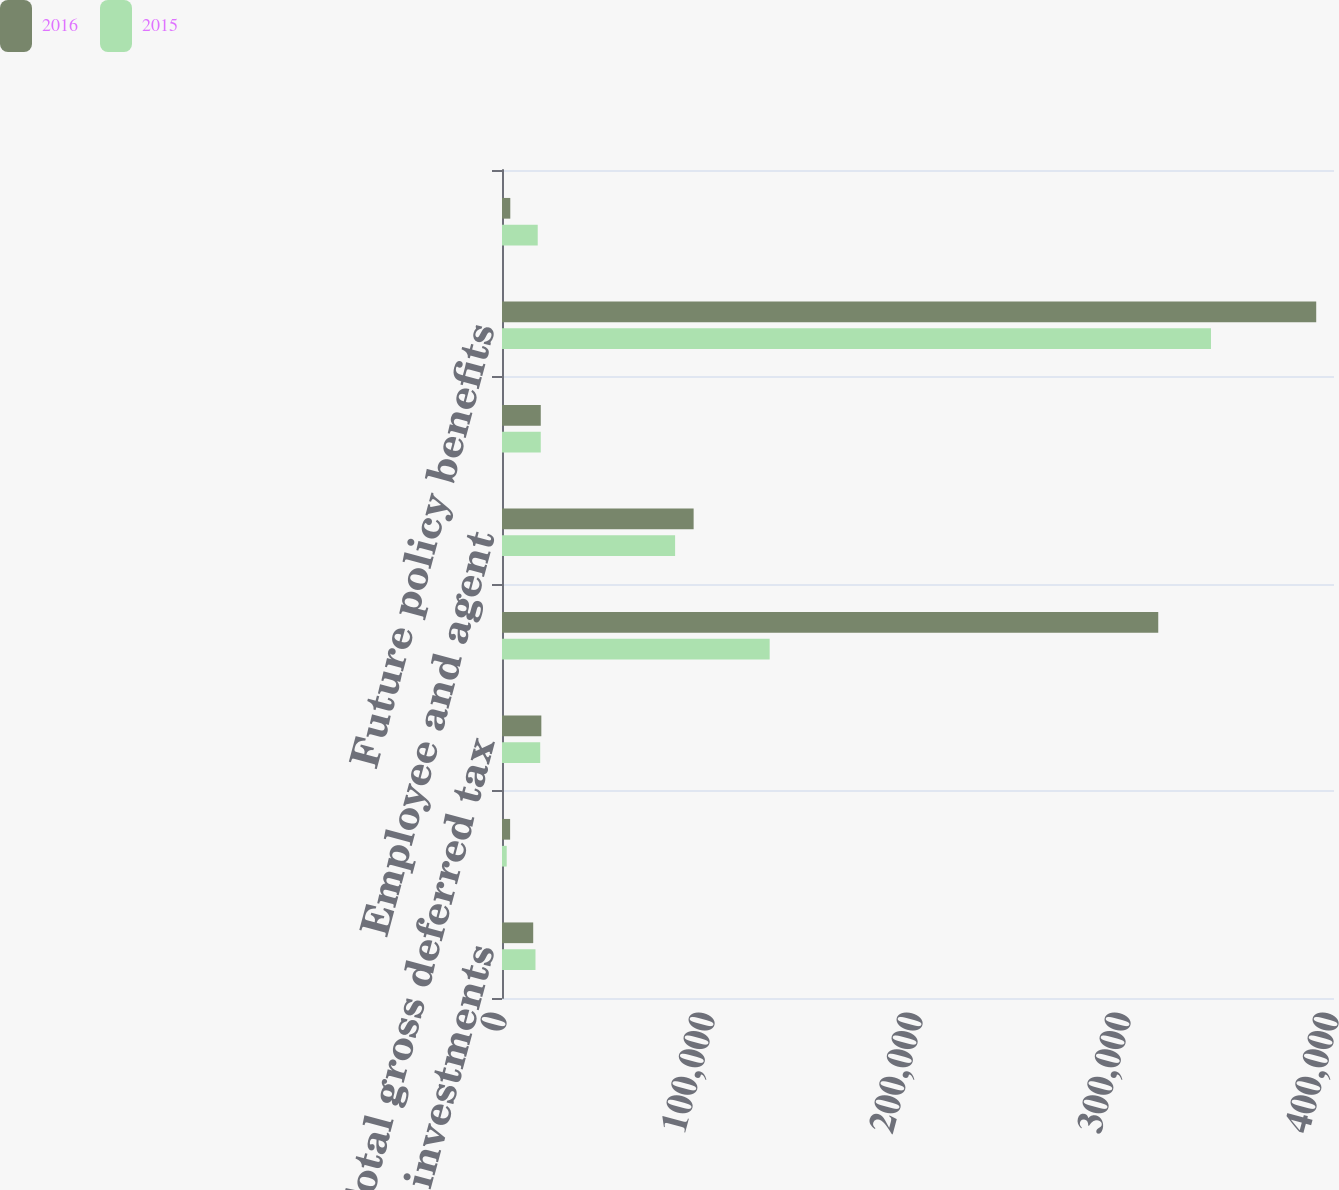Convert chart. <chart><loc_0><loc_0><loc_500><loc_500><stacked_bar_chart><ecel><fcel>Fixed maturity investments<fcel>Carryover of tax losses<fcel>Total gross deferred tax<fcel>Unrealized gains<fcel>Employee and agent<fcel>Deferred acquisition costs<fcel>Future policy benefits<fcel>Other liabilities<nl><fcel>2016<fcel>15004<fcel>3906<fcel>18910<fcel>315509<fcel>92131<fcel>18637<fcel>391451<fcel>3987<nl><fcel>2015<fcel>16098<fcel>2266<fcel>18364<fcel>128683<fcel>83229<fcel>18637<fcel>340854<fcel>17176<nl></chart> 